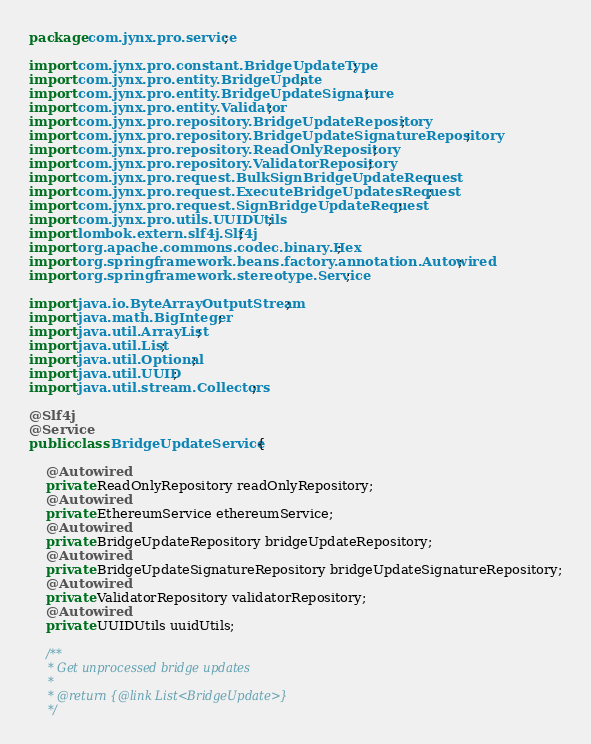Convert code to text. <code><loc_0><loc_0><loc_500><loc_500><_Java_>package com.jynx.pro.service;

import com.jynx.pro.constant.BridgeUpdateType;
import com.jynx.pro.entity.BridgeUpdate;
import com.jynx.pro.entity.BridgeUpdateSignature;
import com.jynx.pro.entity.Validator;
import com.jynx.pro.repository.BridgeUpdateRepository;
import com.jynx.pro.repository.BridgeUpdateSignatureRepository;
import com.jynx.pro.repository.ReadOnlyRepository;
import com.jynx.pro.repository.ValidatorRepository;
import com.jynx.pro.request.BulkSignBridgeUpdateRequest;
import com.jynx.pro.request.ExecuteBridgeUpdatesRequest;
import com.jynx.pro.request.SignBridgeUpdateRequest;
import com.jynx.pro.utils.UUIDUtils;
import lombok.extern.slf4j.Slf4j;
import org.apache.commons.codec.binary.Hex;
import org.springframework.beans.factory.annotation.Autowired;
import org.springframework.stereotype.Service;

import java.io.ByteArrayOutputStream;
import java.math.BigInteger;
import java.util.ArrayList;
import java.util.List;
import java.util.Optional;
import java.util.UUID;
import java.util.stream.Collectors;

@Slf4j
@Service
public class BridgeUpdateService {

    @Autowired
    private ReadOnlyRepository readOnlyRepository;
    @Autowired
    private EthereumService ethereumService;
    @Autowired
    private BridgeUpdateRepository bridgeUpdateRepository;
    @Autowired
    private BridgeUpdateSignatureRepository bridgeUpdateSignatureRepository;
    @Autowired
    private ValidatorRepository validatorRepository;
    @Autowired
    private UUIDUtils uuidUtils;

    /**
     * Get unprocessed bridge updates
     *
     * @return {@link List<BridgeUpdate>}
     */</code> 